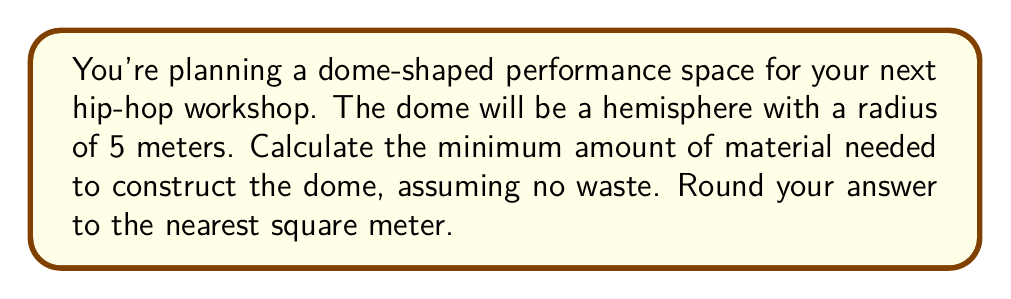Help me with this question. To solve this problem, we need to calculate the surface area of a hemisphere. The formula for the surface area of a hemisphere is:

$$A = 2\pi r^2$$

Where:
$A$ is the surface area
$r$ is the radius of the hemisphere

Let's follow these steps:

1) Substitute the given radius into the formula:
   $$A = 2\pi (5\text{ m})^2$$

2) Simplify the squared term:
   $$A = 2\pi (25\text{ m}^2)$$

3) Multiply:
   $$A = 50\pi\text{ m}^2$$

4) Calculate the result:
   $$A \approx 157.0796\text{ m}^2$$

5) Round to the nearest square meter:
   $$A \approx 157\text{ m}^2$$

[asy]
import geometry;

size(200);
pair O=(0,0);
real r=5;
draw(Circle(O,r));
draw((-r,0)--(r,0));
draw(O--(0,r));
label("r=5m",O--(r/2,r/2),NE);
label("Dome",O--(0,r/2),N);
[/asy]

Therefore, the minimum amount of material needed to construct the dome-shaped performance space is approximately 157 square meters.
Answer: 157 square meters 